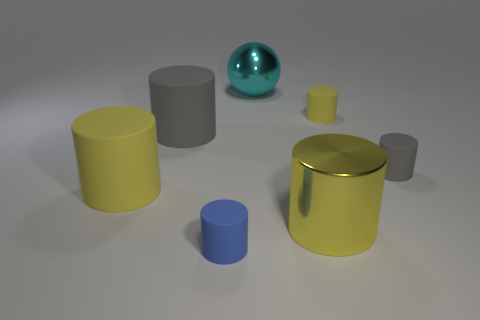How many yellow cylinders must be subtracted to get 1 yellow cylinders? 2 Subtract all large gray rubber cylinders. How many cylinders are left? 5 Subtract all gray cylinders. How many cylinders are left? 4 Subtract 0 yellow blocks. How many objects are left? 7 Subtract all spheres. How many objects are left? 6 Subtract 1 balls. How many balls are left? 0 Subtract all purple cylinders. Subtract all brown cubes. How many cylinders are left? 6 Subtract all red blocks. How many yellow cylinders are left? 3 Subtract all big gray matte things. Subtract all large yellow rubber things. How many objects are left? 5 Add 1 cyan things. How many cyan things are left? 2 